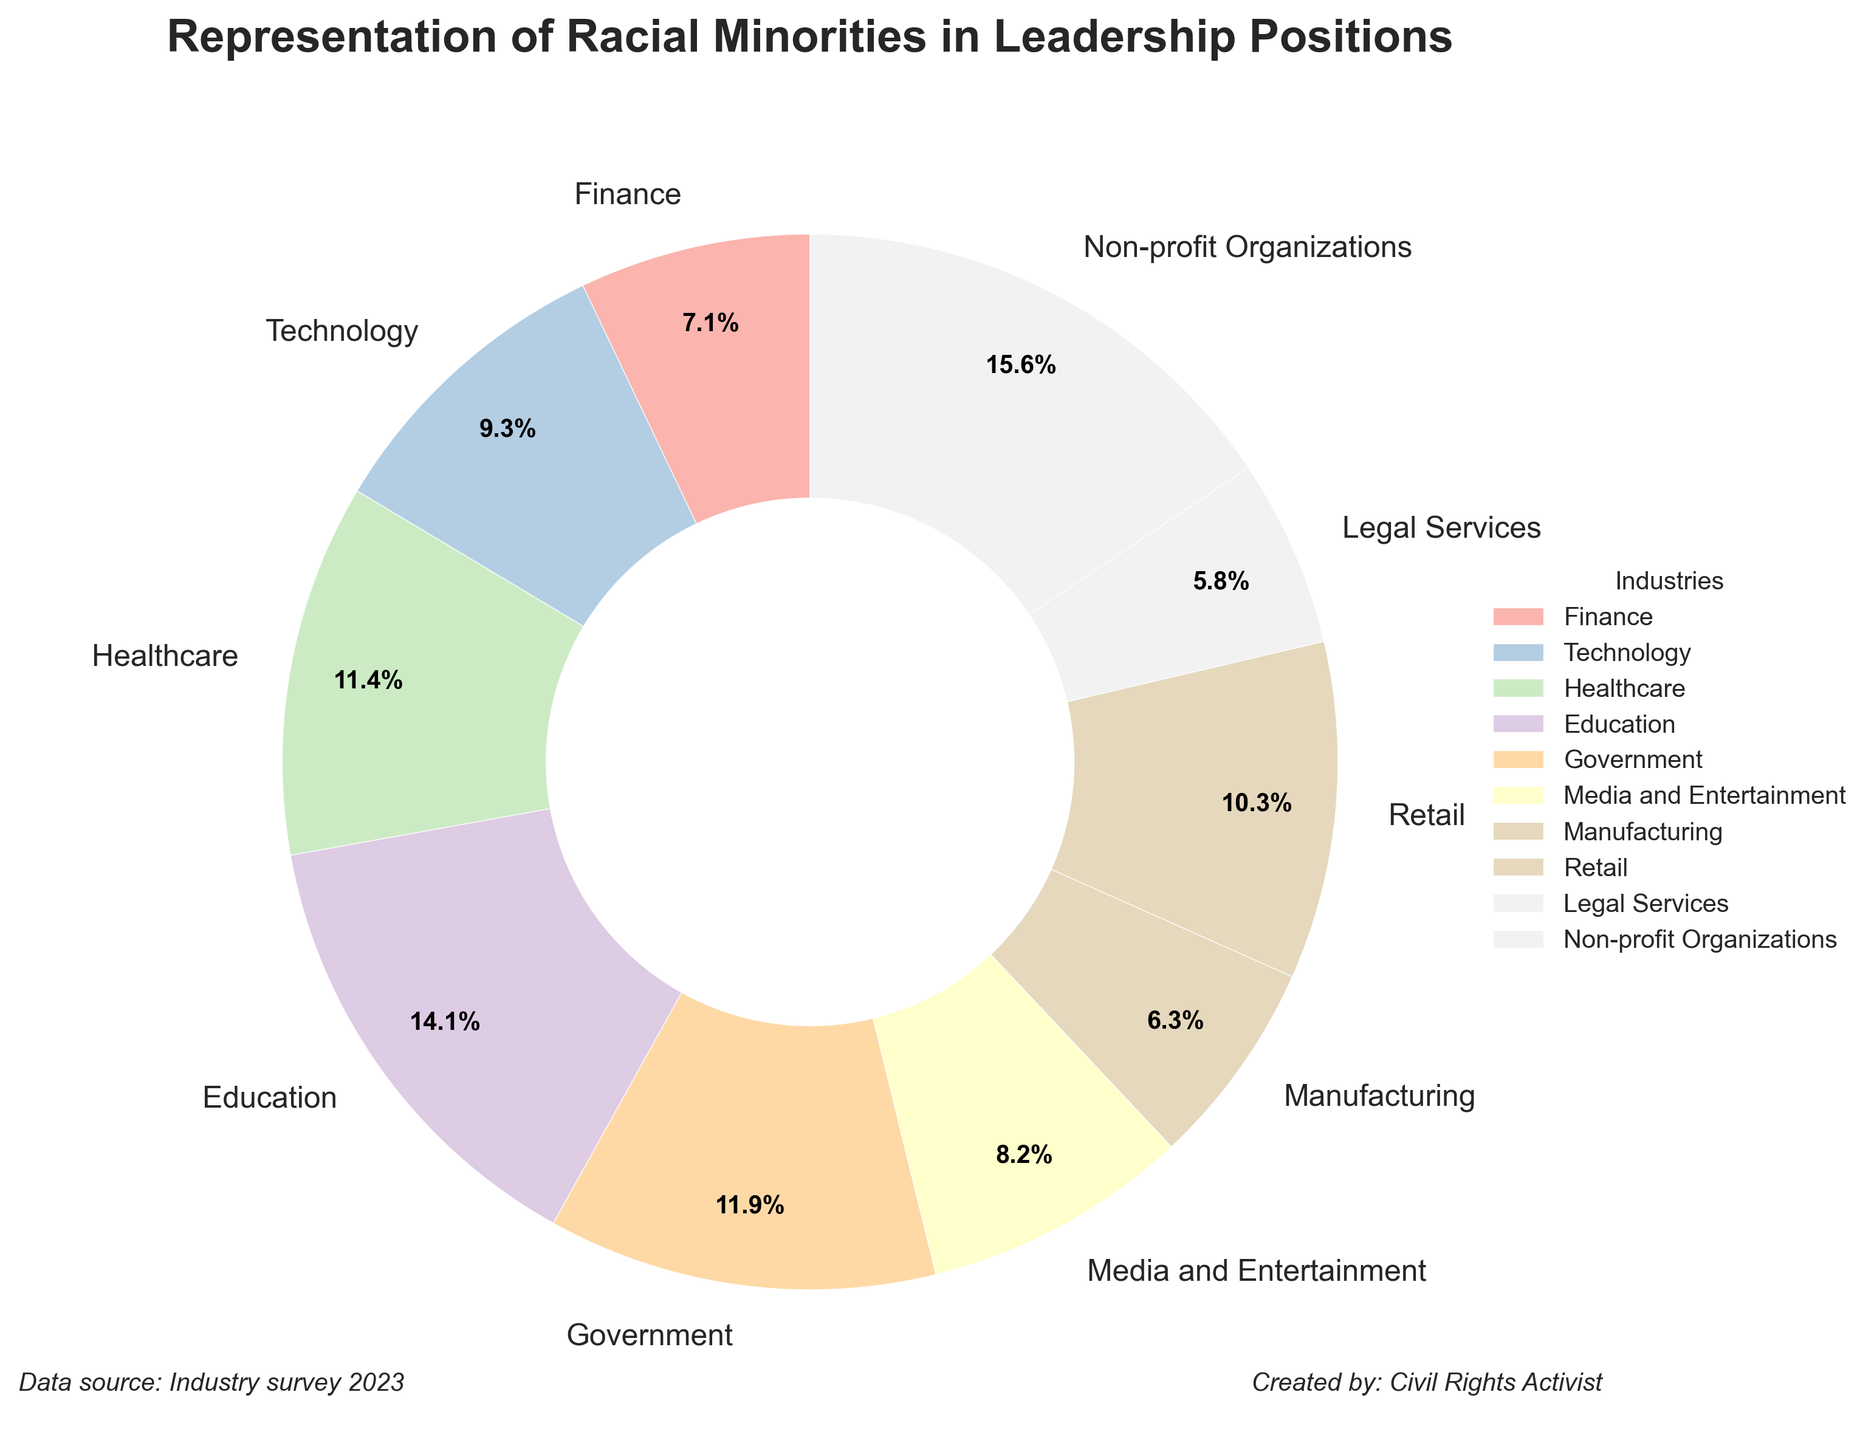What industry has the highest representation of racial minorities in leadership positions? By looking at the figure, the largest slice in the pie chart belongs to Non-profit Organizations.
Answer: Non-profit Organizations What is the total percentage of racial minority representation in the Education and Government sectors combined? Education has 16.9% and Government has 14.3%. Adding these together, 16.9 + 14.3 = 31.2%
Answer: 31.2% Which sector has a lower representation of racial minorities in leadership positions, Manufacturing or Legal Services? Both sectors have relatively smaller slices in the pie chart, but comparing the two, Manufacturing has 7.6% while Legal Services has 6.9%. Legal Services has the lower representation.
Answer: Legal Services What is the average representation percentage across all industries? Sum the percentages and divide by the number of industries. (8.5 + 11.2 + 13.7 + 16.9 + 14.3 + 9.8 + 7.6 + 12.4 + 6.9 + 18.7) / 10 = 120 .
Answer: 12.0% Which industry has a greater representation of racial minorities, Finance or Media and Entertainment? Comparing the sizes of the slices, Finance has 8.5% whereas Media and Entertainment has 9.8%. Media and Entertainment has a greater representation.
Answer: Media and Entertainment What’s the percentage difference between the highest and lowest industries? The highest percentage is Non-profit Organizations with 18.7% and the lowest is Legal Services with 6.9%. The difference is 18.7 - 6.9 = 11.8%.
Answer: 11.8% Which industry has slightly above average representation of racial minorities in leadership positions but isn't the highest? The average representation calculated was 12.0%. Healthcare has a percentage of 13.7% which is above average but not the highest (18.7% for Non-profit Organizations).
Answer: Healthcare Is the Retail sector's representation higher or lower than the Technology sector? Comparing the slices, Retail has 12.4% while Technology has 11.2%. Retail's representation is higher.
Answer: Higher Which sector has nearly double the representation compared to Manufacturing? Manufacturing has 7.6%. Nearly double would be around 15.2%. Education with 16.9% is close to double that of Manufacturing.
Answer: Education 